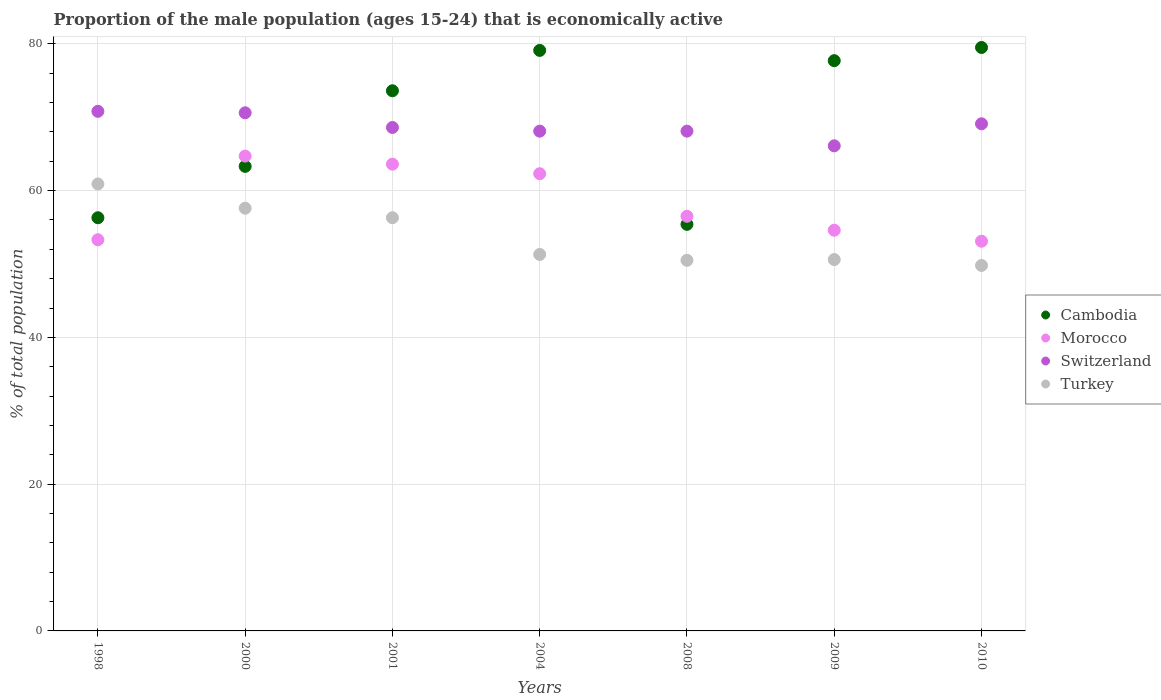What is the proportion of the male population that is economically active in Turkey in 2010?
Keep it short and to the point. 49.8. Across all years, what is the maximum proportion of the male population that is economically active in Morocco?
Your response must be concise. 64.7. Across all years, what is the minimum proportion of the male population that is economically active in Morocco?
Give a very brief answer. 53.1. In which year was the proportion of the male population that is economically active in Switzerland maximum?
Keep it short and to the point. 1998. In which year was the proportion of the male population that is economically active in Switzerland minimum?
Give a very brief answer. 2009. What is the total proportion of the male population that is economically active in Morocco in the graph?
Provide a succinct answer. 408.1. What is the difference between the proportion of the male population that is economically active in Turkey in 1998 and that in 2001?
Keep it short and to the point. 4.6. What is the difference between the proportion of the male population that is economically active in Cambodia in 1998 and the proportion of the male population that is economically active in Switzerland in 2001?
Your answer should be very brief. -12.3. What is the average proportion of the male population that is economically active in Cambodia per year?
Provide a short and direct response. 69.27. In the year 1998, what is the difference between the proportion of the male population that is economically active in Turkey and proportion of the male population that is economically active in Cambodia?
Provide a succinct answer. 4.6. What is the ratio of the proportion of the male population that is economically active in Turkey in 2009 to that in 2010?
Your response must be concise. 1.02. Is the proportion of the male population that is economically active in Turkey in 2000 less than that in 2001?
Offer a very short reply. No. Is the difference between the proportion of the male population that is economically active in Turkey in 2004 and 2009 greater than the difference between the proportion of the male population that is economically active in Cambodia in 2004 and 2009?
Keep it short and to the point. No. What is the difference between the highest and the second highest proportion of the male population that is economically active in Switzerland?
Make the answer very short. 0.2. What is the difference between the highest and the lowest proportion of the male population that is economically active in Cambodia?
Offer a very short reply. 24.1. Is the sum of the proportion of the male population that is economically active in Switzerland in 2000 and 2010 greater than the maximum proportion of the male population that is economically active in Cambodia across all years?
Ensure brevity in your answer.  Yes. Is the proportion of the male population that is economically active in Switzerland strictly greater than the proportion of the male population that is economically active in Morocco over the years?
Offer a terse response. Yes. Is the proportion of the male population that is economically active in Turkey strictly less than the proportion of the male population that is economically active in Morocco over the years?
Your answer should be very brief. No. How many dotlines are there?
Offer a very short reply. 4. Are the values on the major ticks of Y-axis written in scientific E-notation?
Provide a succinct answer. No. Does the graph contain any zero values?
Provide a succinct answer. No. What is the title of the graph?
Make the answer very short. Proportion of the male population (ages 15-24) that is economically active. Does "Hong Kong" appear as one of the legend labels in the graph?
Ensure brevity in your answer.  No. What is the label or title of the X-axis?
Offer a terse response. Years. What is the label or title of the Y-axis?
Offer a very short reply. % of total population. What is the % of total population of Cambodia in 1998?
Your answer should be compact. 56.3. What is the % of total population of Morocco in 1998?
Your response must be concise. 53.3. What is the % of total population of Switzerland in 1998?
Offer a very short reply. 70.8. What is the % of total population of Turkey in 1998?
Offer a terse response. 60.9. What is the % of total population in Cambodia in 2000?
Keep it short and to the point. 63.3. What is the % of total population in Morocco in 2000?
Your answer should be compact. 64.7. What is the % of total population of Switzerland in 2000?
Give a very brief answer. 70.6. What is the % of total population of Turkey in 2000?
Your answer should be compact. 57.6. What is the % of total population of Cambodia in 2001?
Offer a terse response. 73.6. What is the % of total population of Morocco in 2001?
Provide a succinct answer. 63.6. What is the % of total population in Switzerland in 2001?
Provide a succinct answer. 68.6. What is the % of total population of Turkey in 2001?
Provide a short and direct response. 56.3. What is the % of total population of Cambodia in 2004?
Provide a succinct answer. 79.1. What is the % of total population of Morocco in 2004?
Offer a very short reply. 62.3. What is the % of total population of Switzerland in 2004?
Give a very brief answer. 68.1. What is the % of total population in Turkey in 2004?
Ensure brevity in your answer.  51.3. What is the % of total population in Cambodia in 2008?
Provide a short and direct response. 55.4. What is the % of total population in Morocco in 2008?
Give a very brief answer. 56.5. What is the % of total population of Switzerland in 2008?
Give a very brief answer. 68.1. What is the % of total population in Turkey in 2008?
Offer a very short reply. 50.5. What is the % of total population in Cambodia in 2009?
Give a very brief answer. 77.7. What is the % of total population in Morocco in 2009?
Offer a very short reply. 54.6. What is the % of total population of Switzerland in 2009?
Your answer should be compact. 66.1. What is the % of total population in Turkey in 2009?
Your answer should be very brief. 50.6. What is the % of total population in Cambodia in 2010?
Offer a terse response. 79.5. What is the % of total population of Morocco in 2010?
Provide a short and direct response. 53.1. What is the % of total population in Switzerland in 2010?
Provide a succinct answer. 69.1. What is the % of total population in Turkey in 2010?
Ensure brevity in your answer.  49.8. Across all years, what is the maximum % of total population of Cambodia?
Offer a terse response. 79.5. Across all years, what is the maximum % of total population of Morocco?
Provide a short and direct response. 64.7. Across all years, what is the maximum % of total population of Switzerland?
Your answer should be very brief. 70.8. Across all years, what is the maximum % of total population in Turkey?
Your answer should be very brief. 60.9. Across all years, what is the minimum % of total population in Cambodia?
Your answer should be very brief. 55.4. Across all years, what is the minimum % of total population in Morocco?
Give a very brief answer. 53.1. Across all years, what is the minimum % of total population of Switzerland?
Provide a short and direct response. 66.1. Across all years, what is the minimum % of total population of Turkey?
Provide a short and direct response. 49.8. What is the total % of total population of Cambodia in the graph?
Make the answer very short. 484.9. What is the total % of total population in Morocco in the graph?
Give a very brief answer. 408.1. What is the total % of total population in Switzerland in the graph?
Offer a very short reply. 481.4. What is the total % of total population in Turkey in the graph?
Your answer should be compact. 377. What is the difference between the % of total population of Turkey in 1998 and that in 2000?
Your answer should be compact. 3.3. What is the difference between the % of total population of Cambodia in 1998 and that in 2001?
Make the answer very short. -17.3. What is the difference between the % of total population in Morocco in 1998 and that in 2001?
Your response must be concise. -10.3. What is the difference between the % of total population in Switzerland in 1998 and that in 2001?
Provide a short and direct response. 2.2. What is the difference between the % of total population of Cambodia in 1998 and that in 2004?
Keep it short and to the point. -22.8. What is the difference between the % of total population in Switzerland in 1998 and that in 2008?
Provide a succinct answer. 2.7. What is the difference between the % of total population of Turkey in 1998 and that in 2008?
Offer a terse response. 10.4. What is the difference between the % of total population of Cambodia in 1998 and that in 2009?
Give a very brief answer. -21.4. What is the difference between the % of total population of Switzerland in 1998 and that in 2009?
Provide a short and direct response. 4.7. What is the difference between the % of total population of Turkey in 1998 and that in 2009?
Keep it short and to the point. 10.3. What is the difference between the % of total population in Cambodia in 1998 and that in 2010?
Provide a succinct answer. -23.2. What is the difference between the % of total population of Morocco in 1998 and that in 2010?
Your answer should be compact. 0.2. What is the difference between the % of total population of Turkey in 1998 and that in 2010?
Make the answer very short. 11.1. What is the difference between the % of total population in Cambodia in 2000 and that in 2001?
Your answer should be compact. -10.3. What is the difference between the % of total population of Morocco in 2000 and that in 2001?
Offer a terse response. 1.1. What is the difference between the % of total population in Turkey in 2000 and that in 2001?
Provide a short and direct response. 1.3. What is the difference between the % of total population in Cambodia in 2000 and that in 2004?
Provide a succinct answer. -15.8. What is the difference between the % of total population of Cambodia in 2000 and that in 2008?
Give a very brief answer. 7.9. What is the difference between the % of total population in Turkey in 2000 and that in 2008?
Provide a succinct answer. 7.1. What is the difference between the % of total population of Cambodia in 2000 and that in 2009?
Offer a terse response. -14.4. What is the difference between the % of total population of Morocco in 2000 and that in 2009?
Provide a succinct answer. 10.1. What is the difference between the % of total population of Switzerland in 2000 and that in 2009?
Your answer should be compact. 4.5. What is the difference between the % of total population of Cambodia in 2000 and that in 2010?
Ensure brevity in your answer.  -16.2. What is the difference between the % of total population in Switzerland in 2000 and that in 2010?
Your answer should be compact. 1.5. What is the difference between the % of total population in Morocco in 2001 and that in 2004?
Your answer should be very brief. 1.3. What is the difference between the % of total population of Switzerland in 2001 and that in 2004?
Give a very brief answer. 0.5. What is the difference between the % of total population of Turkey in 2001 and that in 2004?
Provide a short and direct response. 5. What is the difference between the % of total population in Morocco in 2001 and that in 2008?
Your answer should be very brief. 7.1. What is the difference between the % of total population of Turkey in 2001 and that in 2008?
Provide a short and direct response. 5.8. What is the difference between the % of total population in Cambodia in 2001 and that in 2009?
Offer a very short reply. -4.1. What is the difference between the % of total population of Cambodia in 2001 and that in 2010?
Your answer should be compact. -5.9. What is the difference between the % of total population of Morocco in 2001 and that in 2010?
Make the answer very short. 10.5. What is the difference between the % of total population in Cambodia in 2004 and that in 2008?
Your answer should be very brief. 23.7. What is the difference between the % of total population in Switzerland in 2004 and that in 2008?
Provide a short and direct response. 0. What is the difference between the % of total population in Cambodia in 2004 and that in 2009?
Offer a very short reply. 1.4. What is the difference between the % of total population of Morocco in 2004 and that in 2009?
Make the answer very short. 7.7. What is the difference between the % of total population in Switzerland in 2004 and that in 2010?
Keep it short and to the point. -1. What is the difference between the % of total population of Turkey in 2004 and that in 2010?
Offer a very short reply. 1.5. What is the difference between the % of total population of Cambodia in 2008 and that in 2009?
Your response must be concise. -22.3. What is the difference between the % of total population in Switzerland in 2008 and that in 2009?
Your answer should be compact. 2. What is the difference between the % of total population in Cambodia in 2008 and that in 2010?
Your answer should be very brief. -24.1. What is the difference between the % of total population of Morocco in 2008 and that in 2010?
Ensure brevity in your answer.  3.4. What is the difference between the % of total population of Turkey in 2008 and that in 2010?
Make the answer very short. 0.7. What is the difference between the % of total population of Switzerland in 2009 and that in 2010?
Make the answer very short. -3. What is the difference between the % of total population in Turkey in 2009 and that in 2010?
Your answer should be compact. 0.8. What is the difference between the % of total population of Cambodia in 1998 and the % of total population of Switzerland in 2000?
Make the answer very short. -14.3. What is the difference between the % of total population of Cambodia in 1998 and the % of total population of Turkey in 2000?
Your answer should be compact. -1.3. What is the difference between the % of total population of Morocco in 1998 and the % of total population of Switzerland in 2000?
Ensure brevity in your answer.  -17.3. What is the difference between the % of total population in Morocco in 1998 and the % of total population in Turkey in 2000?
Ensure brevity in your answer.  -4.3. What is the difference between the % of total population of Switzerland in 1998 and the % of total population of Turkey in 2000?
Give a very brief answer. 13.2. What is the difference between the % of total population of Cambodia in 1998 and the % of total population of Turkey in 2001?
Keep it short and to the point. 0. What is the difference between the % of total population in Morocco in 1998 and the % of total population in Switzerland in 2001?
Your answer should be compact. -15.3. What is the difference between the % of total population of Cambodia in 1998 and the % of total population of Turkey in 2004?
Ensure brevity in your answer.  5. What is the difference between the % of total population of Morocco in 1998 and the % of total population of Switzerland in 2004?
Keep it short and to the point. -14.8. What is the difference between the % of total population in Cambodia in 1998 and the % of total population in Morocco in 2008?
Ensure brevity in your answer.  -0.2. What is the difference between the % of total population in Cambodia in 1998 and the % of total population in Turkey in 2008?
Your answer should be very brief. 5.8. What is the difference between the % of total population of Morocco in 1998 and the % of total population of Switzerland in 2008?
Ensure brevity in your answer.  -14.8. What is the difference between the % of total population of Morocco in 1998 and the % of total population of Turkey in 2008?
Offer a terse response. 2.8. What is the difference between the % of total population of Switzerland in 1998 and the % of total population of Turkey in 2008?
Provide a short and direct response. 20.3. What is the difference between the % of total population in Cambodia in 1998 and the % of total population in Morocco in 2009?
Your answer should be very brief. 1.7. What is the difference between the % of total population of Cambodia in 1998 and the % of total population of Switzerland in 2009?
Your response must be concise. -9.8. What is the difference between the % of total population in Cambodia in 1998 and the % of total population in Turkey in 2009?
Your response must be concise. 5.7. What is the difference between the % of total population of Morocco in 1998 and the % of total population of Turkey in 2009?
Your answer should be compact. 2.7. What is the difference between the % of total population of Switzerland in 1998 and the % of total population of Turkey in 2009?
Offer a very short reply. 20.2. What is the difference between the % of total population of Cambodia in 1998 and the % of total population of Turkey in 2010?
Ensure brevity in your answer.  6.5. What is the difference between the % of total population in Morocco in 1998 and the % of total population in Switzerland in 2010?
Give a very brief answer. -15.8. What is the difference between the % of total population of Switzerland in 1998 and the % of total population of Turkey in 2010?
Your answer should be compact. 21. What is the difference between the % of total population in Cambodia in 2000 and the % of total population in Morocco in 2001?
Your response must be concise. -0.3. What is the difference between the % of total population in Cambodia in 2000 and the % of total population in Switzerland in 2001?
Give a very brief answer. -5.3. What is the difference between the % of total population of Cambodia in 2000 and the % of total population of Switzerland in 2004?
Keep it short and to the point. -4.8. What is the difference between the % of total population in Cambodia in 2000 and the % of total population in Turkey in 2004?
Provide a short and direct response. 12. What is the difference between the % of total population in Morocco in 2000 and the % of total population in Switzerland in 2004?
Offer a terse response. -3.4. What is the difference between the % of total population in Morocco in 2000 and the % of total population in Turkey in 2004?
Offer a very short reply. 13.4. What is the difference between the % of total population of Switzerland in 2000 and the % of total population of Turkey in 2004?
Provide a short and direct response. 19.3. What is the difference between the % of total population of Cambodia in 2000 and the % of total population of Switzerland in 2008?
Provide a succinct answer. -4.8. What is the difference between the % of total population of Switzerland in 2000 and the % of total population of Turkey in 2008?
Offer a terse response. 20.1. What is the difference between the % of total population of Cambodia in 2000 and the % of total population of Switzerland in 2009?
Provide a succinct answer. -2.8. What is the difference between the % of total population of Morocco in 2000 and the % of total population of Switzerland in 2009?
Ensure brevity in your answer.  -1.4. What is the difference between the % of total population in Morocco in 2000 and the % of total population in Turkey in 2009?
Offer a very short reply. 14.1. What is the difference between the % of total population of Switzerland in 2000 and the % of total population of Turkey in 2009?
Ensure brevity in your answer.  20. What is the difference between the % of total population in Switzerland in 2000 and the % of total population in Turkey in 2010?
Your answer should be compact. 20.8. What is the difference between the % of total population in Cambodia in 2001 and the % of total population in Morocco in 2004?
Make the answer very short. 11.3. What is the difference between the % of total population of Cambodia in 2001 and the % of total population of Switzerland in 2004?
Keep it short and to the point. 5.5. What is the difference between the % of total population of Cambodia in 2001 and the % of total population of Turkey in 2004?
Offer a terse response. 22.3. What is the difference between the % of total population in Morocco in 2001 and the % of total population in Turkey in 2004?
Keep it short and to the point. 12.3. What is the difference between the % of total population of Cambodia in 2001 and the % of total population of Morocco in 2008?
Your response must be concise. 17.1. What is the difference between the % of total population of Cambodia in 2001 and the % of total population of Turkey in 2008?
Make the answer very short. 23.1. What is the difference between the % of total population in Morocco in 2001 and the % of total population in Switzerland in 2008?
Provide a short and direct response. -4.5. What is the difference between the % of total population in Morocco in 2001 and the % of total population in Turkey in 2008?
Your answer should be compact. 13.1. What is the difference between the % of total population of Cambodia in 2001 and the % of total population of Turkey in 2009?
Your answer should be very brief. 23. What is the difference between the % of total population of Morocco in 2001 and the % of total population of Switzerland in 2009?
Offer a very short reply. -2.5. What is the difference between the % of total population in Cambodia in 2001 and the % of total population in Morocco in 2010?
Your answer should be compact. 20.5. What is the difference between the % of total population of Cambodia in 2001 and the % of total population of Switzerland in 2010?
Ensure brevity in your answer.  4.5. What is the difference between the % of total population in Cambodia in 2001 and the % of total population in Turkey in 2010?
Provide a succinct answer. 23.8. What is the difference between the % of total population in Cambodia in 2004 and the % of total population in Morocco in 2008?
Your answer should be compact. 22.6. What is the difference between the % of total population of Cambodia in 2004 and the % of total population of Switzerland in 2008?
Your answer should be very brief. 11. What is the difference between the % of total population of Cambodia in 2004 and the % of total population of Turkey in 2008?
Ensure brevity in your answer.  28.6. What is the difference between the % of total population in Morocco in 2004 and the % of total population in Switzerland in 2008?
Your answer should be very brief. -5.8. What is the difference between the % of total population in Cambodia in 2004 and the % of total population in Morocco in 2009?
Your response must be concise. 24.5. What is the difference between the % of total population in Cambodia in 2004 and the % of total population in Switzerland in 2009?
Offer a terse response. 13. What is the difference between the % of total population in Cambodia in 2004 and the % of total population in Turkey in 2009?
Your response must be concise. 28.5. What is the difference between the % of total population of Morocco in 2004 and the % of total population of Switzerland in 2009?
Ensure brevity in your answer.  -3.8. What is the difference between the % of total population of Morocco in 2004 and the % of total population of Turkey in 2009?
Give a very brief answer. 11.7. What is the difference between the % of total population in Switzerland in 2004 and the % of total population in Turkey in 2009?
Offer a terse response. 17.5. What is the difference between the % of total population in Cambodia in 2004 and the % of total population in Switzerland in 2010?
Offer a very short reply. 10. What is the difference between the % of total population in Cambodia in 2004 and the % of total population in Turkey in 2010?
Give a very brief answer. 29.3. What is the difference between the % of total population of Switzerland in 2004 and the % of total population of Turkey in 2010?
Provide a short and direct response. 18.3. What is the difference between the % of total population in Cambodia in 2008 and the % of total population in Morocco in 2009?
Make the answer very short. 0.8. What is the difference between the % of total population in Cambodia in 2008 and the % of total population in Switzerland in 2009?
Your response must be concise. -10.7. What is the difference between the % of total population of Morocco in 2008 and the % of total population of Switzerland in 2009?
Your response must be concise. -9.6. What is the difference between the % of total population in Morocco in 2008 and the % of total population in Turkey in 2009?
Offer a very short reply. 5.9. What is the difference between the % of total population of Cambodia in 2008 and the % of total population of Morocco in 2010?
Keep it short and to the point. 2.3. What is the difference between the % of total population of Cambodia in 2008 and the % of total population of Switzerland in 2010?
Your answer should be very brief. -13.7. What is the difference between the % of total population in Cambodia in 2008 and the % of total population in Turkey in 2010?
Keep it short and to the point. 5.6. What is the difference between the % of total population of Switzerland in 2008 and the % of total population of Turkey in 2010?
Provide a succinct answer. 18.3. What is the difference between the % of total population in Cambodia in 2009 and the % of total population in Morocco in 2010?
Your answer should be compact. 24.6. What is the difference between the % of total population of Cambodia in 2009 and the % of total population of Turkey in 2010?
Your answer should be compact. 27.9. What is the difference between the % of total population in Morocco in 2009 and the % of total population in Switzerland in 2010?
Make the answer very short. -14.5. What is the difference between the % of total population of Morocco in 2009 and the % of total population of Turkey in 2010?
Offer a very short reply. 4.8. What is the difference between the % of total population of Switzerland in 2009 and the % of total population of Turkey in 2010?
Offer a very short reply. 16.3. What is the average % of total population in Cambodia per year?
Ensure brevity in your answer.  69.27. What is the average % of total population of Morocco per year?
Give a very brief answer. 58.3. What is the average % of total population in Switzerland per year?
Make the answer very short. 68.77. What is the average % of total population of Turkey per year?
Offer a very short reply. 53.86. In the year 1998, what is the difference between the % of total population of Morocco and % of total population of Switzerland?
Provide a succinct answer. -17.5. In the year 1998, what is the difference between the % of total population in Morocco and % of total population in Turkey?
Provide a succinct answer. -7.6. In the year 2000, what is the difference between the % of total population in Cambodia and % of total population in Switzerland?
Provide a short and direct response. -7.3. In the year 2000, what is the difference between the % of total population in Cambodia and % of total population in Turkey?
Give a very brief answer. 5.7. In the year 2000, what is the difference between the % of total population of Morocco and % of total population of Switzerland?
Your answer should be compact. -5.9. In the year 2000, what is the difference between the % of total population in Morocco and % of total population in Turkey?
Your response must be concise. 7.1. In the year 2001, what is the difference between the % of total population of Morocco and % of total population of Turkey?
Provide a succinct answer. 7.3. In the year 2001, what is the difference between the % of total population of Switzerland and % of total population of Turkey?
Offer a very short reply. 12.3. In the year 2004, what is the difference between the % of total population in Cambodia and % of total population in Morocco?
Offer a very short reply. 16.8. In the year 2004, what is the difference between the % of total population of Cambodia and % of total population of Switzerland?
Ensure brevity in your answer.  11. In the year 2004, what is the difference between the % of total population in Cambodia and % of total population in Turkey?
Your answer should be compact. 27.8. In the year 2004, what is the difference between the % of total population in Morocco and % of total population in Switzerland?
Provide a succinct answer. -5.8. In the year 2004, what is the difference between the % of total population in Morocco and % of total population in Turkey?
Your response must be concise. 11. In the year 2004, what is the difference between the % of total population of Switzerland and % of total population of Turkey?
Your answer should be compact. 16.8. In the year 2008, what is the difference between the % of total population of Cambodia and % of total population of Morocco?
Give a very brief answer. -1.1. In the year 2008, what is the difference between the % of total population in Cambodia and % of total population in Turkey?
Offer a terse response. 4.9. In the year 2008, what is the difference between the % of total population of Morocco and % of total population of Turkey?
Keep it short and to the point. 6. In the year 2009, what is the difference between the % of total population of Cambodia and % of total population of Morocco?
Your answer should be compact. 23.1. In the year 2009, what is the difference between the % of total population in Cambodia and % of total population in Switzerland?
Offer a very short reply. 11.6. In the year 2009, what is the difference between the % of total population in Cambodia and % of total population in Turkey?
Provide a short and direct response. 27.1. In the year 2009, what is the difference between the % of total population of Morocco and % of total population of Switzerland?
Ensure brevity in your answer.  -11.5. In the year 2009, what is the difference between the % of total population in Morocco and % of total population in Turkey?
Provide a short and direct response. 4. In the year 2010, what is the difference between the % of total population of Cambodia and % of total population of Morocco?
Provide a short and direct response. 26.4. In the year 2010, what is the difference between the % of total population of Cambodia and % of total population of Switzerland?
Offer a terse response. 10.4. In the year 2010, what is the difference between the % of total population of Cambodia and % of total population of Turkey?
Provide a short and direct response. 29.7. In the year 2010, what is the difference between the % of total population in Morocco and % of total population in Switzerland?
Make the answer very short. -16. In the year 2010, what is the difference between the % of total population in Switzerland and % of total population in Turkey?
Your answer should be very brief. 19.3. What is the ratio of the % of total population in Cambodia in 1998 to that in 2000?
Your answer should be compact. 0.89. What is the ratio of the % of total population of Morocco in 1998 to that in 2000?
Provide a succinct answer. 0.82. What is the ratio of the % of total population in Turkey in 1998 to that in 2000?
Your answer should be compact. 1.06. What is the ratio of the % of total population of Cambodia in 1998 to that in 2001?
Make the answer very short. 0.76. What is the ratio of the % of total population in Morocco in 1998 to that in 2001?
Ensure brevity in your answer.  0.84. What is the ratio of the % of total population of Switzerland in 1998 to that in 2001?
Give a very brief answer. 1.03. What is the ratio of the % of total population in Turkey in 1998 to that in 2001?
Keep it short and to the point. 1.08. What is the ratio of the % of total population of Cambodia in 1998 to that in 2004?
Provide a short and direct response. 0.71. What is the ratio of the % of total population in Morocco in 1998 to that in 2004?
Your answer should be compact. 0.86. What is the ratio of the % of total population of Switzerland in 1998 to that in 2004?
Your answer should be very brief. 1.04. What is the ratio of the % of total population of Turkey in 1998 to that in 2004?
Make the answer very short. 1.19. What is the ratio of the % of total population of Cambodia in 1998 to that in 2008?
Give a very brief answer. 1.02. What is the ratio of the % of total population of Morocco in 1998 to that in 2008?
Keep it short and to the point. 0.94. What is the ratio of the % of total population of Switzerland in 1998 to that in 2008?
Offer a very short reply. 1.04. What is the ratio of the % of total population in Turkey in 1998 to that in 2008?
Your answer should be very brief. 1.21. What is the ratio of the % of total population of Cambodia in 1998 to that in 2009?
Give a very brief answer. 0.72. What is the ratio of the % of total population in Morocco in 1998 to that in 2009?
Provide a succinct answer. 0.98. What is the ratio of the % of total population of Switzerland in 1998 to that in 2009?
Give a very brief answer. 1.07. What is the ratio of the % of total population of Turkey in 1998 to that in 2009?
Provide a succinct answer. 1.2. What is the ratio of the % of total population in Cambodia in 1998 to that in 2010?
Your answer should be compact. 0.71. What is the ratio of the % of total population in Switzerland in 1998 to that in 2010?
Make the answer very short. 1.02. What is the ratio of the % of total population in Turkey in 1998 to that in 2010?
Offer a terse response. 1.22. What is the ratio of the % of total population of Cambodia in 2000 to that in 2001?
Your answer should be very brief. 0.86. What is the ratio of the % of total population of Morocco in 2000 to that in 2001?
Provide a succinct answer. 1.02. What is the ratio of the % of total population of Switzerland in 2000 to that in 2001?
Make the answer very short. 1.03. What is the ratio of the % of total population of Turkey in 2000 to that in 2001?
Provide a succinct answer. 1.02. What is the ratio of the % of total population in Cambodia in 2000 to that in 2004?
Make the answer very short. 0.8. What is the ratio of the % of total population in Morocco in 2000 to that in 2004?
Provide a succinct answer. 1.04. What is the ratio of the % of total population in Switzerland in 2000 to that in 2004?
Provide a short and direct response. 1.04. What is the ratio of the % of total population of Turkey in 2000 to that in 2004?
Ensure brevity in your answer.  1.12. What is the ratio of the % of total population in Cambodia in 2000 to that in 2008?
Your response must be concise. 1.14. What is the ratio of the % of total population of Morocco in 2000 to that in 2008?
Give a very brief answer. 1.15. What is the ratio of the % of total population in Switzerland in 2000 to that in 2008?
Keep it short and to the point. 1.04. What is the ratio of the % of total population of Turkey in 2000 to that in 2008?
Your answer should be very brief. 1.14. What is the ratio of the % of total population in Cambodia in 2000 to that in 2009?
Offer a terse response. 0.81. What is the ratio of the % of total population in Morocco in 2000 to that in 2009?
Provide a short and direct response. 1.19. What is the ratio of the % of total population in Switzerland in 2000 to that in 2009?
Offer a very short reply. 1.07. What is the ratio of the % of total population of Turkey in 2000 to that in 2009?
Your response must be concise. 1.14. What is the ratio of the % of total population in Cambodia in 2000 to that in 2010?
Your response must be concise. 0.8. What is the ratio of the % of total population in Morocco in 2000 to that in 2010?
Make the answer very short. 1.22. What is the ratio of the % of total population in Switzerland in 2000 to that in 2010?
Give a very brief answer. 1.02. What is the ratio of the % of total population of Turkey in 2000 to that in 2010?
Offer a terse response. 1.16. What is the ratio of the % of total population of Cambodia in 2001 to that in 2004?
Ensure brevity in your answer.  0.93. What is the ratio of the % of total population in Morocco in 2001 to that in 2004?
Ensure brevity in your answer.  1.02. What is the ratio of the % of total population of Switzerland in 2001 to that in 2004?
Offer a terse response. 1.01. What is the ratio of the % of total population in Turkey in 2001 to that in 2004?
Ensure brevity in your answer.  1.1. What is the ratio of the % of total population of Cambodia in 2001 to that in 2008?
Offer a terse response. 1.33. What is the ratio of the % of total population of Morocco in 2001 to that in 2008?
Keep it short and to the point. 1.13. What is the ratio of the % of total population of Switzerland in 2001 to that in 2008?
Your response must be concise. 1.01. What is the ratio of the % of total population in Turkey in 2001 to that in 2008?
Keep it short and to the point. 1.11. What is the ratio of the % of total population of Cambodia in 2001 to that in 2009?
Give a very brief answer. 0.95. What is the ratio of the % of total population in Morocco in 2001 to that in 2009?
Provide a short and direct response. 1.16. What is the ratio of the % of total population in Switzerland in 2001 to that in 2009?
Offer a very short reply. 1.04. What is the ratio of the % of total population in Turkey in 2001 to that in 2009?
Your answer should be compact. 1.11. What is the ratio of the % of total population in Cambodia in 2001 to that in 2010?
Your answer should be compact. 0.93. What is the ratio of the % of total population in Morocco in 2001 to that in 2010?
Provide a short and direct response. 1.2. What is the ratio of the % of total population of Switzerland in 2001 to that in 2010?
Make the answer very short. 0.99. What is the ratio of the % of total population in Turkey in 2001 to that in 2010?
Make the answer very short. 1.13. What is the ratio of the % of total population in Cambodia in 2004 to that in 2008?
Offer a very short reply. 1.43. What is the ratio of the % of total population in Morocco in 2004 to that in 2008?
Provide a succinct answer. 1.1. What is the ratio of the % of total population of Switzerland in 2004 to that in 2008?
Give a very brief answer. 1. What is the ratio of the % of total population of Turkey in 2004 to that in 2008?
Your response must be concise. 1.02. What is the ratio of the % of total population of Morocco in 2004 to that in 2009?
Your answer should be very brief. 1.14. What is the ratio of the % of total population in Switzerland in 2004 to that in 2009?
Provide a short and direct response. 1.03. What is the ratio of the % of total population in Turkey in 2004 to that in 2009?
Your response must be concise. 1.01. What is the ratio of the % of total population in Morocco in 2004 to that in 2010?
Your response must be concise. 1.17. What is the ratio of the % of total population of Switzerland in 2004 to that in 2010?
Make the answer very short. 0.99. What is the ratio of the % of total population of Turkey in 2004 to that in 2010?
Keep it short and to the point. 1.03. What is the ratio of the % of total population of Cambodia in 2008 to that in 2009?
Ensure brevity in your answer.  0.71. What is the ratio of the % of total population of Morocco in 2008 to that in 2009?
Your answer should be compact. 1.03. What is the ratio of the % of total population of Switzerland in 2008 to that in 2009?
Provide a short and direct response. 1.03. What is the ratio of the % of total population in Cambodia in 2008 to that in 2010?
Make the answer very short. 0.7. What is the ratio of the % of total population of Morocco in 2008 to that in 2010?
Provide a succinct answer. 1.06. What is the ratio of the % of total population of Switzerland in 2008 to that in 2010?
Your answer should be compact. 0.99. What is the ratio of the % of total population in Turkey in 2008 to that in 2010?
Your answer should be compact. 1.01. What is the ratio of the % of total population in Cambodia in 2009 to that in 2010?
Offer a terse response. 0.98. What is the ratio of the % of total population in Morocco in 2009 to that in 2010?
Your response must be concise. 1.03. What is the ratio of the % of total population of Switzerland in 2009 to that in 2010?
Provide a succinct answer. 0.96. What is the ratio of the % of total population of Turkey in 2009 to that in 2010?
Your answer should be very brief. 1.02. What is the difference between the highest and the second highest % of total population in Cambodia?
Give a very brief answer. 0.4. What is the difference between the highest and the lowest % of total population of Cambodia?
Keep it short and to the point. 24.1. What is the difference between the highest and the lowest % of total population of Morocco?
Your answer should be compact. 11.6. What is the difference between the highest and the lowest % of total population in Switzerland?
Your answer should be compact. 4.7. What is the difference between the highest and the lowest % of total population in Turkey?
Give a very brief answer. 11.1. 